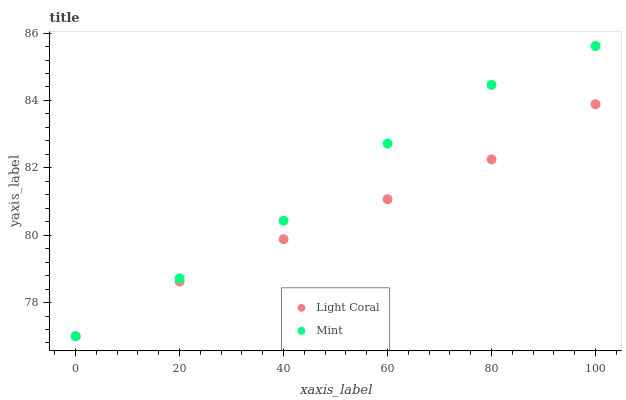Does Light Coral have the minimum area under the curve?
Answer yes or no. Yes. Does Mint have the maximum area under the curve?
Answer yes or no. Yes. Does Mint have the minimum area under the curve?
Answer yes or no. No. Is Light Coral the smoothest?
Answer yes or no. Yes. Is Mint the roughest?
Answer yes or no. Yes. Is Mint the smoothest?
Answer yes or no. No. Does Light Coral have the lowest value?
Answer yes or no. Yes. Does Mint have the highest value?
Answer yes or no. Yes. Does Light Coral intersect Mint?
Answer yes or no. Yes. Is Light Coral less than Mint?
Answer yes or no. No. Is Light Coral greater than Mint?
Answer yes or no. No. 